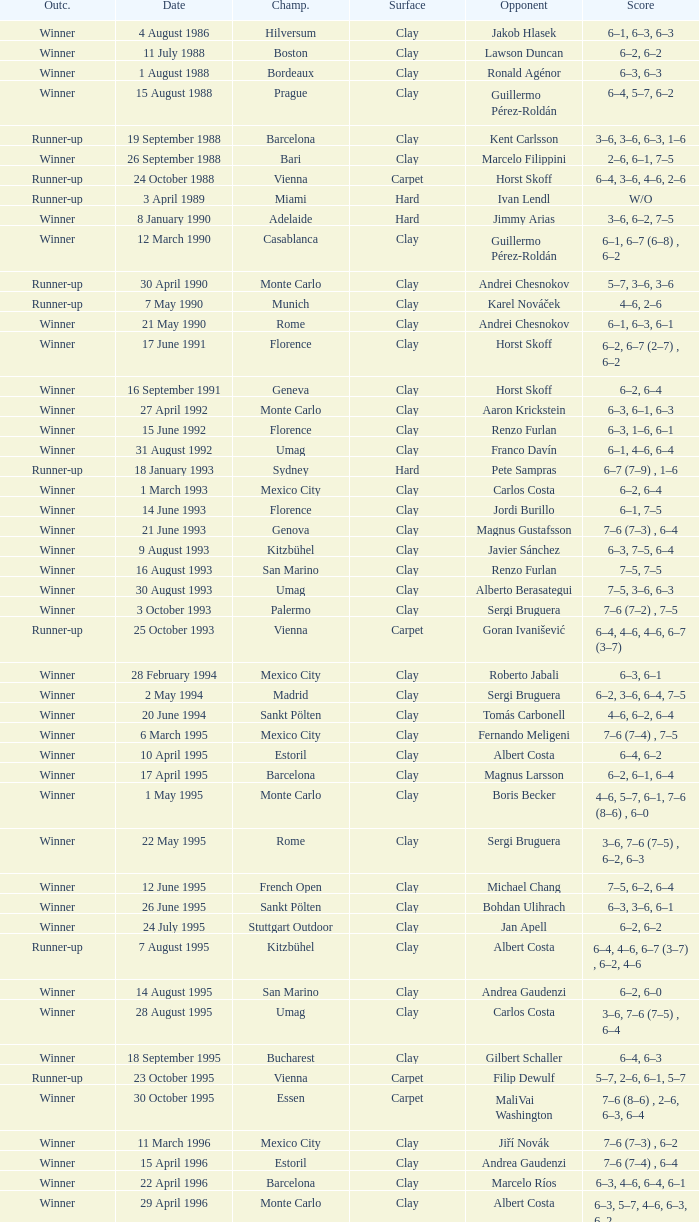Could you help me parse every detail presented in this table? {'header': ['Outc.', 'Date', 'Champ.', 'Surface', 'Opponent', 'Score'], 'rows': [['Winner', '4 August 1986', 'Hilversum', 'Clay', 'Jakob Hlasek', '6–1, 6–3, 6–3'], ['Winner', '11 July 1988', 'Boston', 'Clay', 'Lawson Duncan', '6–2, 6–2'], ['Winner', '1 August 1988', 'Bordeaux', 'Clay', 'Ronald Agénor', '6–3, 6–3'], ['Winner', '15 August 1988', 'Prague', 'Clay', 'Guillermo Pérez-Roldán', '6–4, 5–7, 6–2'], ['Runner-up', '19 September 1988', 'Barcelona', 'Clay', 'Kent Carlsson', '3–6, 3–6, 6–3, 1–6'], ['Winner', '26 September 1988', 'Bari', 'Clay', 'Marcelo Filippini', '2–6, 6–1, 7–5'], ['Runner-up', '24 October 1988', 'Vienna', 'Carpet', 'Horst Skoff', '6–4, 3–6, 4–6, 2–6'], ['Runner-up', '3 April 1989', 'Miami', 'Hard', 'Ivan Lendl', 'W/O'], ['Winner', '8 January 1990', 'Adelaide', 'Hard', 'Jimmy Arias', '3–6, 6–2, 7–5'], ['Winner', '12 March 1990', 'Casablanca', 'Clay', 'Guillermo Pérez-Roldán', '6–1, 6–7 (6–8) , 6–2'], ['Runner-up', '30 April 1990', 'Monte Carlo', 'Clay', 'Andrei Chesnokov', '5–7, 3–6, 3–6'], ['Runner-up', '7 May 1990', 'Munich', 'Clay', 'Karel Nováček', '4–6, 2–6'], ['Winner', '21 May 1990', 'Rome', 'Clay', 'Andrei Chesnokov', '6–1, 6–3, 6–1'], ['Winner', '17 June 1991', 'Florence', 'Clay', 'Horst Skoff', '6–2, 6–7 (2–7) , 6–2'], ['Winner', '16 September 1991', 'Geneva', 'Clay', 'Horst Skoff', '6–2, 6–4'], ['Winner', '27 April 1992', 'Monte Carlo', 'Clay', 'Aaron Krickstein', '6–3, 6–1, 6–3'], ['Winner', '15 June 1992', 'Florence', 'Clay', 'Renzo Furlan', '6–3, 1–6, 6–1'], ['Winner', '31 August 1992', 'Umag', 'Clay', 'Franco Davín', '6–1, 4–6, 6–4'], ['Runner-up', '18 January 1993', 'Sydney', 'Hard', 'Pete Sampras', '6–7 (7–9) , 1–6'], ['Winner', '1 March 1993', 'Mexico City', 'Clay', 'Carlos Costa', '6–2, 6–4'], ['Winner', '14 June 1993', 'Florence', 'Clay', 'Jordi Burillo', '6–1, 7–5'], ['Winner', '21 June 1993', 'Genova', 'Clay', 'Magnus Gustafsson', '7–6 (7–3) , 6–4'], ['Winner', '9 August 1993', 'Kitzbühel', 'Clay', 'Javier Sánchez', '6–3, 7–5, 6–4'], ['Winner', '16 August 1993', 'San Marino', 'Clay', 'Renzo Furlan', '7–5, 7–5'], ['Winner', '30 August 1993', 'Umag', 'Clay', 'Alberto Berasategui', '7–5, 3–6, 6–3'], ['Winner', '3 October 1993', 'Palermo', 'Clay', 'Sergi Bruguera', '7–6 (7–2) , 7–5'], ['Runner-up', '25 October 1993', 'Vienna', 'Carpet', 'Goran Ivanišević', '6–4, 4–6, 4–6, 6–7 (3–7)'], ['Winner', '28 February 1994', 'Mexico City', 'Clay', 'Roberto Jabali', '6–3, 6–1'], ['Winner', '2 May 1994', 'Madrid', 'Clay', 'Sergi Bruguera', '6–2, 3–6, 6–4, 7–5'], ['Winner', '20 June 1994', 'Sankt Pölten', 'Clay', 'Tomás Carbonell', '4–6, 6–2, 6–4'], ['Winner', '6 March 1995', 'Mexico City', 'Clay', 'Fernando Meligeni', '7–6 (7–4) , 7–5'], ['Winner', '10 April 1995', 'Estoril', 'Clay', 'Albert Costa', '6–4, 6–2'], ['Winner', '17 April 1995', 'Barcelona', 'Clay', 'Magnus Larsson', '6–2, 6–1, 6–4'], ['Winner', '1 May 1995', 'Monte Carlo', 'Clay', 'Boris Becker', '4–6, 5–7, 6–1, 7–6 (8–6) , 6–0'], ['Winner', '22 May 1995', 'Rome', 'Clay', 'Sergi Bruguera', '3–6, 7–6 (7–5) , 6–2, 6–3'], ['Winner', '12 June 1995', 'French Open', 'Clay', 'Michael Chang', '7–5, 6–2, 6–4'], ['Winner', '26 June 1995', 'Sankt Pölten', 'Clay', 'Bohdan Ulihrach', '6–3, 3–6, 6–1'], ['Winner', '24 July 1995', 'Stuttgart Outdoor', 'Clay', 'Jan Apell', '6–2, 6–2'], ['Runner-up', '7 August 1995', 'Kitzbühel', 'Clay', 'Albert Costa', '6–4, 4–6, 6–7 (3–7) , 6–2, 4–6'], ['Winner', '14 August 1995', 'San Marino', 'Clay', 'Andrea Gaudenzi', '6–2, 6–0'], ['Winner', '28 August 1995', 'Umag', 'Clay', 'Carlos Costa', '3–6, 7–6 (7–5) , 6–4'], ['Winner', '18 September 1995', 'Bucharest', 'Clay', 'Gilbert Schaller', '6–4, 6–3'], ['Runner-up', '23 October 1995', 'Vienna', 'Carpet', 'Filip Dewulf', '5–7, 2–6, 6–1, 5–7'], ['Winner', '30 October 1995', 'Essen', 'Carpet', 'MaliVai Washington', '7–6 (8–6) , 2–6, 6–3, 6–4'], ['Winner', '11 March 1996', 'Mexico City', 'Clay', 'Jiří Novák', '7–6 (7–3) , 6–2'], ['Winner', '15 April 1996', 'Estoril', 'Clay', 'Andrea Gaudenzi', '7–6 (7–4) , 6–4'], ['Winner', '22 April 1996', 'Barcelona', 'Clay', 'Marcelo Ríos', '6–3, 4–6, 6–4, 6–1'], ['Winner', '29 April 1996', 'Monte Carlo', 'Clay', 'Albert Costa', '6–3, 5–7, 4–6, 6–3, 6–2'], ['Winner', '20 May 1996', 'Rome', 'Clay', 'Richard Krajicek', '6–2, 6–4, 3–6, 6–3'], ['Winner', '22 July 1996', 'Stuttgart Outdoor', 'Clay', 'Yevgeny Kafelnikov', '6–2, 6–2, 6–4'], ['Winner', '16 September 1996', 'Bogotá', 'Clay', 'Nicolás Lapentti', '6–7 (6–8) , 6–2, 6–3'], ['Winner', '17 February 1997', 'Dubai', 'Hard', 'Goran Ivanišević', '7–5, 7–6 (7–3)'], ['Winner', '31 March 1997', 'Miami', 'Hard', 'Sergi Bruguera', '7–6 (8–6) , 6–3, 6–1'], ['Runner-up', '11 August 1997', 'Cincinnati', 'Hard', 'Pete Sampras', '3–6, 4–6'], ['Runner-up', '13 April 1998', 'Estoril', 'Clay', 'Alberto Berasategui', '6–3, 1–6, 3–6']]} Who is the opponent when the surface is clay, the outcome is winner and the championship is estoril on 15 april 1996? Andrea Gaudenzi. 